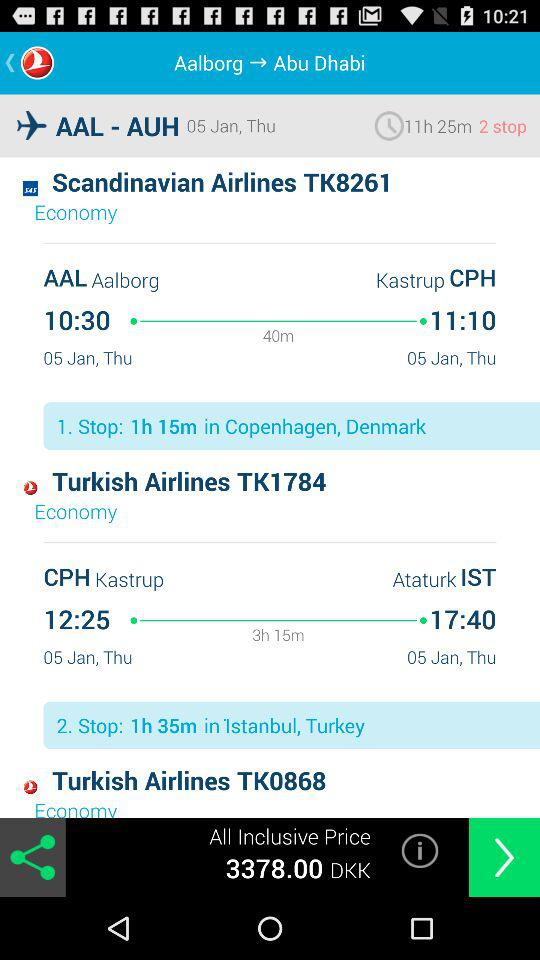What is the travel time from AAL to CPH by "Scandinavian Airlines TK8261"? The travel time from AAL to CPH is 40 minutes. 